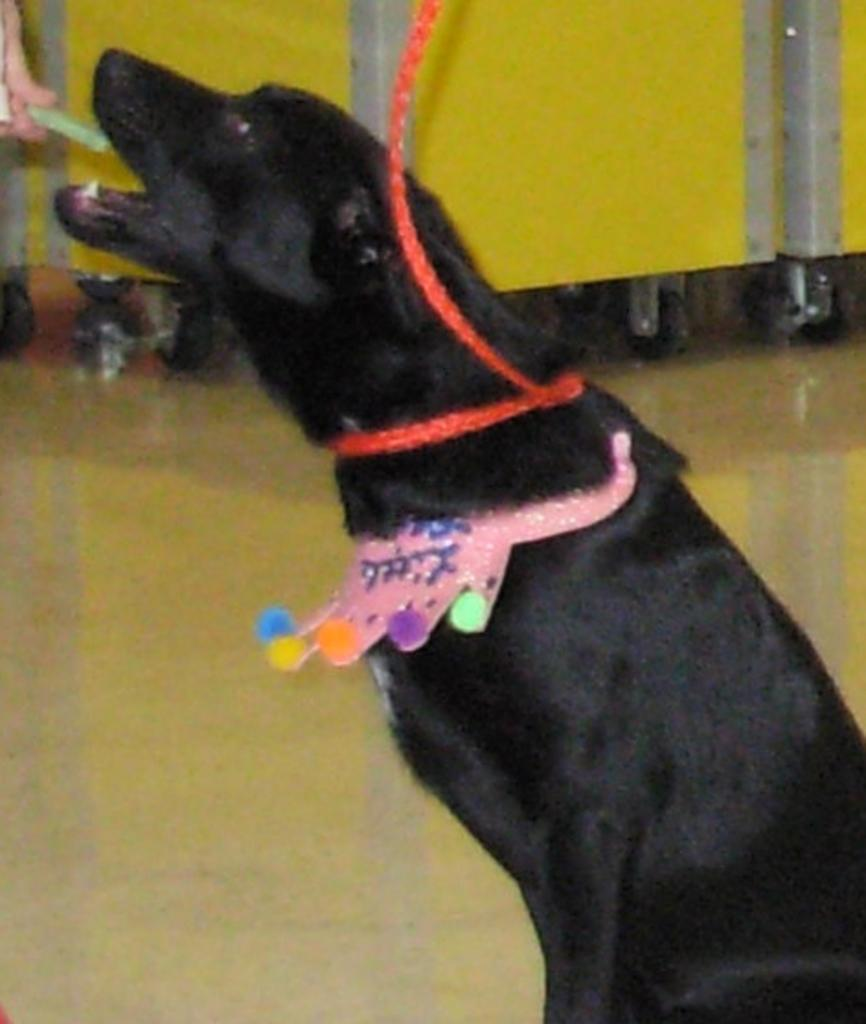What animal is present in the image? There is a dog in the image. Where is the dog located in the image? The dog is in the middle of the image. How is the dog secured or restrained in the image? The dog is tied with a belt. What type of pin can be seen holding the structure together in the image? There is no pin or structure present in the image; it features a dog tied with a belt. 